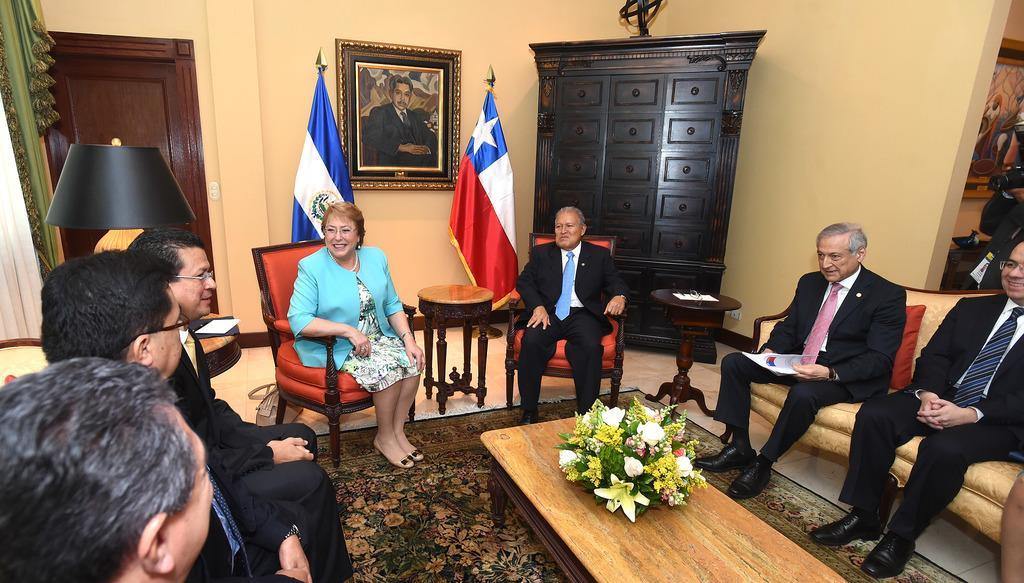In one or two sentences, can you explain what this image depicts? The image is inside the room. In the image there are group of people sitting on chair in front of a table, on table we can see a flower pot with some flowers in middle of the image we can see two flags and a photo frame on wall. On left side there is a door which is closed,curtains and a table, lamp on that table at bottom there is a mat. 